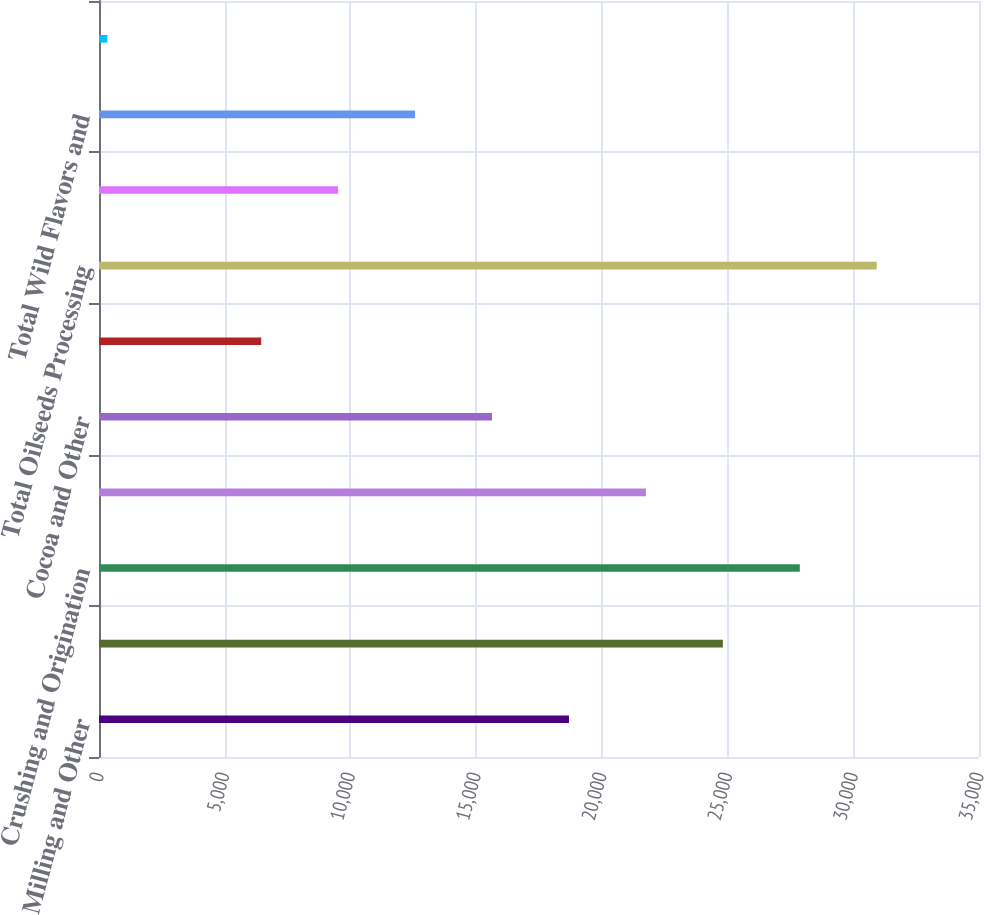Convert chart. <chart><loc_0><loc_0><loc_500><loc_500><bar_chart><fcel>Milling and Other<fcel>Total Corn Processing<fcel>Crushing and Origination<fcel>Refining Packaging Biodiesel<fcel>Cocoa and Other<fcel>Asia<fcel>Total Oilseeds Processing<fcel>Wild Flavors and Specialty<fcel>Total Wild Flavors and<fcel>Other - Financial<nl><fcel>18691.8<fcel>24812.4<fcel>27872.7<fcel>21752.1<fcel>15631.5<fcel>6450.6<fcel>30933<fcel>9510.9<fcel>12571.2<fcel>330<nl></chart> 